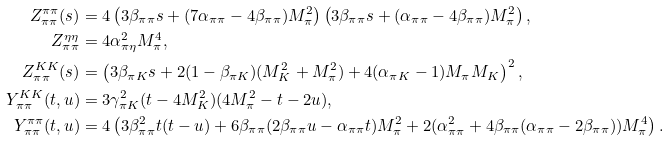<formula> <loc_0><loc_0><loc_500><loc_500>Z _ { \pi \pi } ^ { \pi \pi } ( s ) & = 4 \left ( 3 \beta _ { \pi \pi } s + ( 7 \alpha _ { \pi \pi } - 4 \beta _ { \pi \pi } ) M _ { \pi } ^ { 2 } \right ) \left ( 3 \beta _ { \pi \pi } s + ( \alpha _ { \pi \pi } - 4 \beta _ { \pi \pi } ) M _ { \pi } ^ { 2 } \right ) , \\ Z ^ { \eta \eta } _ { \pi \pi } & = 4 \alpha _ { \pi \eta } ^ { 2 } M _ { \pi } ^ { 4 } , \\ Z ^ { K K } _ { \pi \pi } ( s ) & = \left ( 3 \beta _ { \pi K } s + 2 ( 1 - \beta _ { \pi K } ) ( M _ { K } ^ { 2 } + M _ { \pi } ^ { 2 } ) + 4 ( \alpha _ { \pi K } - 1 ) M _ { \pi } M _ { K } \right ) ^ { 2 } , \\ Y ^ { K K } _ { \pi \pi } ( t , u ) & = 3 \gamma _ { \pi K } ^ { 2 } ( t - 4 M _ { K } ^ { 2 } ) ( 4 M _ { \pi } ^ { 2 } - t - 2 u ) , \\ Y _ { \pi \pi } ^ { \pi \pi } ( t , u ) & = 4 \left ( 3 \beta _ { \pi \pi } ^ { 2 } t ( t - u ) + 6 \beta _ { \pi \pi } ( 2 \beta _ { \pi \pi } u - \alpha _ { \pi \pi } t ) M _ { \pi } ^ { 2 } + 2 ( \alpha _ { \pi \pi } ^ { 2 } + 4 \beta _ { \pi \pi } ( \alpha _ { \pi \pi } - 2 \beta _ { \pi \pi } ) ) M _ { \pi } ^ { 4 } \right ) .</formula> 